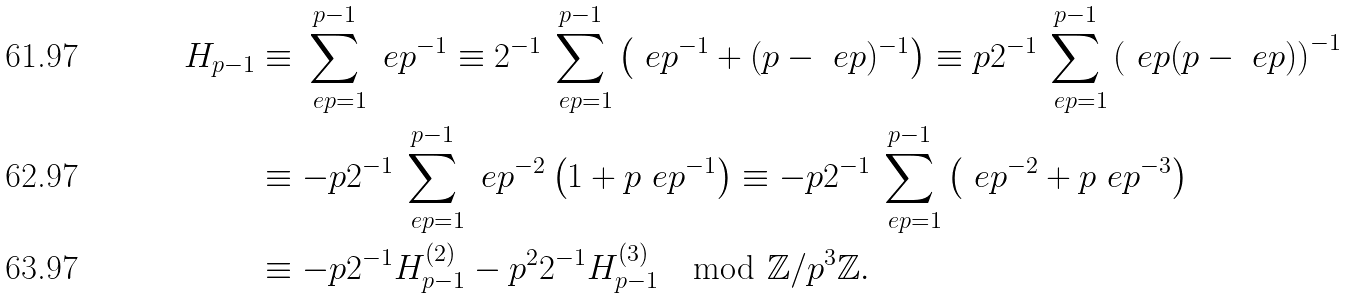<formula> <loc_0><loc_0><loc_500><loc_500>H _ { p - 1 } & \equiv \sum _ { \ e p = 1 } ^ { p - 1 } \ e p ^ { - 1 } \equiv 2 ^ { - 1 } \sum _ { \ e p = 1 } ^ { p - 1 } \left ( \ e p ^ { - 1 } + ( p - \ e p ) ^ { - 1 } \right ) \equiv p 2 ^ { - 1 } \sum _ { \ e p = 1 } ^ { p - 1 } \left ( \ e p ( p - \ e p ) \right ) ^ { - 1 } \\ & \equiv - p 2 ^ { - 1 } \sum _ { \ e p = 1 } ^ { p - 1 } \ e p ^ { - 2 } \left ( 1 + p \ e p ^ { - 1 } \right ) \equiv - p 2 ^ { - 1 } \sum _ { \ e p = 1 } ^ { p - 1 } \left ( \ e p ^ { - 2 } + p \ e p ^ { - 3 } \right ) \\ & \equiv - p 2 ^ { - 1 } H _ { p - 1 } ^ { ( 2 ) } - p ^ { 2 } 2 ^ { - 1 } H _ { p - 1 } ^ { ( 3 ) } \mod \mathbb { Z } / p ^ { 3 } \mathbb { Z } .</formula> 